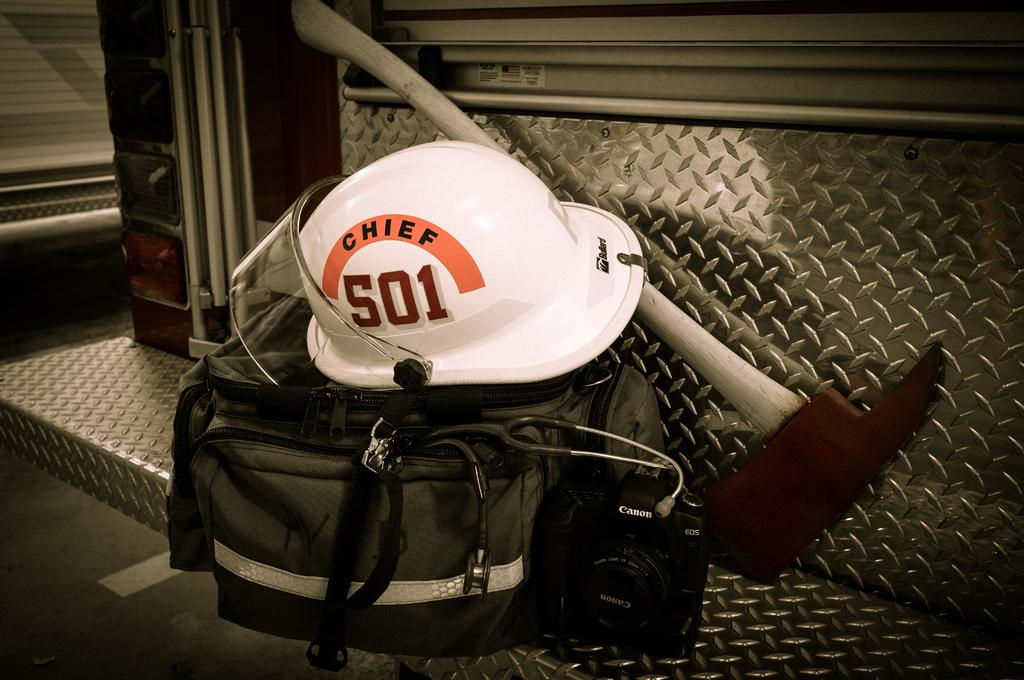What type of protective gear is visible in the image? There is a helmet in the image. What can be used for carrying items in the image? There is a bag in the image. What device is used for capturing images in the image? There is a camera in the image. What medical tool is present in the image? There is a stethoscope in the image. What object is placed on the metal bench in the image? There is an object on the metal bench in the image. How is the metal bench connected to the vehicle in the image? The metal bench is attached to a vehicle in the image. Where is the tent set up in the image? There is no tent present in the image. What type of war equipment can be seen in the image? There is no war equipment present in the image. 